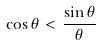<formula> <loc_0><loc_0><loc_500><loc_500>\cos \theta < \frac { \sin \theta } { \theta }</formula> 